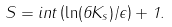<formula> <loc_0><loc_0><loc_500><loc_500>S = i n t \left ( \ln ( 6 K _ { s } ) / \epsilon \right ) + 1 .</formula> 